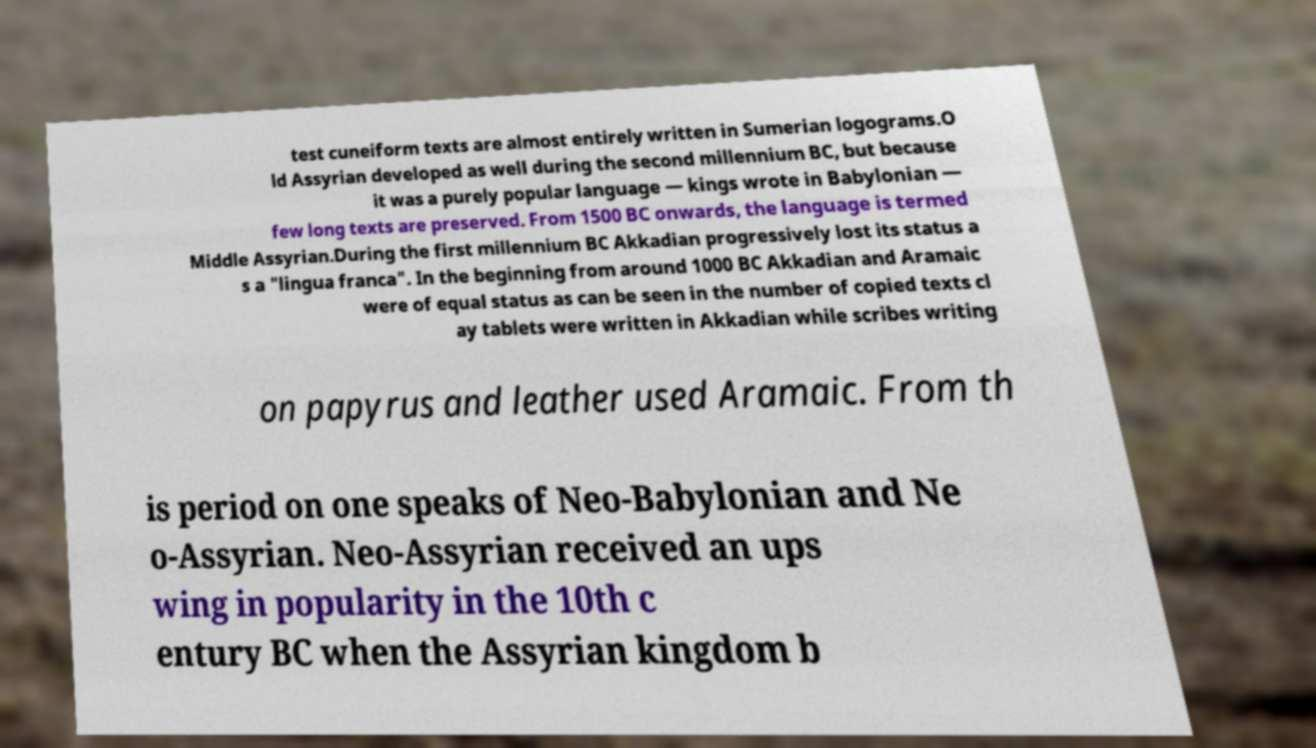There's text embedded in this image that I need extracted. Can you transcribe it verbatim? test cuneiform texts are almost entirely written in Sumerian logograms.O ld Assyrian developed as well during the second millennium BC, but because it was a purely popular language — kings wrote in Babylonian — few long texts are preserved. From 1500 BC onwards, the language is termed Middle Assyrian.During the first millennium BC Akkadian progressively lost its status a s a "lingua franca". In the beginning from around 1000 BC Akkadian and Aramaic were of equal status as can be seen in the number of copied texts cl ay tablets were written in Akkadian while scribes writing on papyrus and leather used Aramaic. From th is period on one speaks of Neo-Babylonian and Ne o-Assyrian. Neo-Assyrian received an ups wing in popularity in the 10th c entury BC when the Assyrian kingdom b 